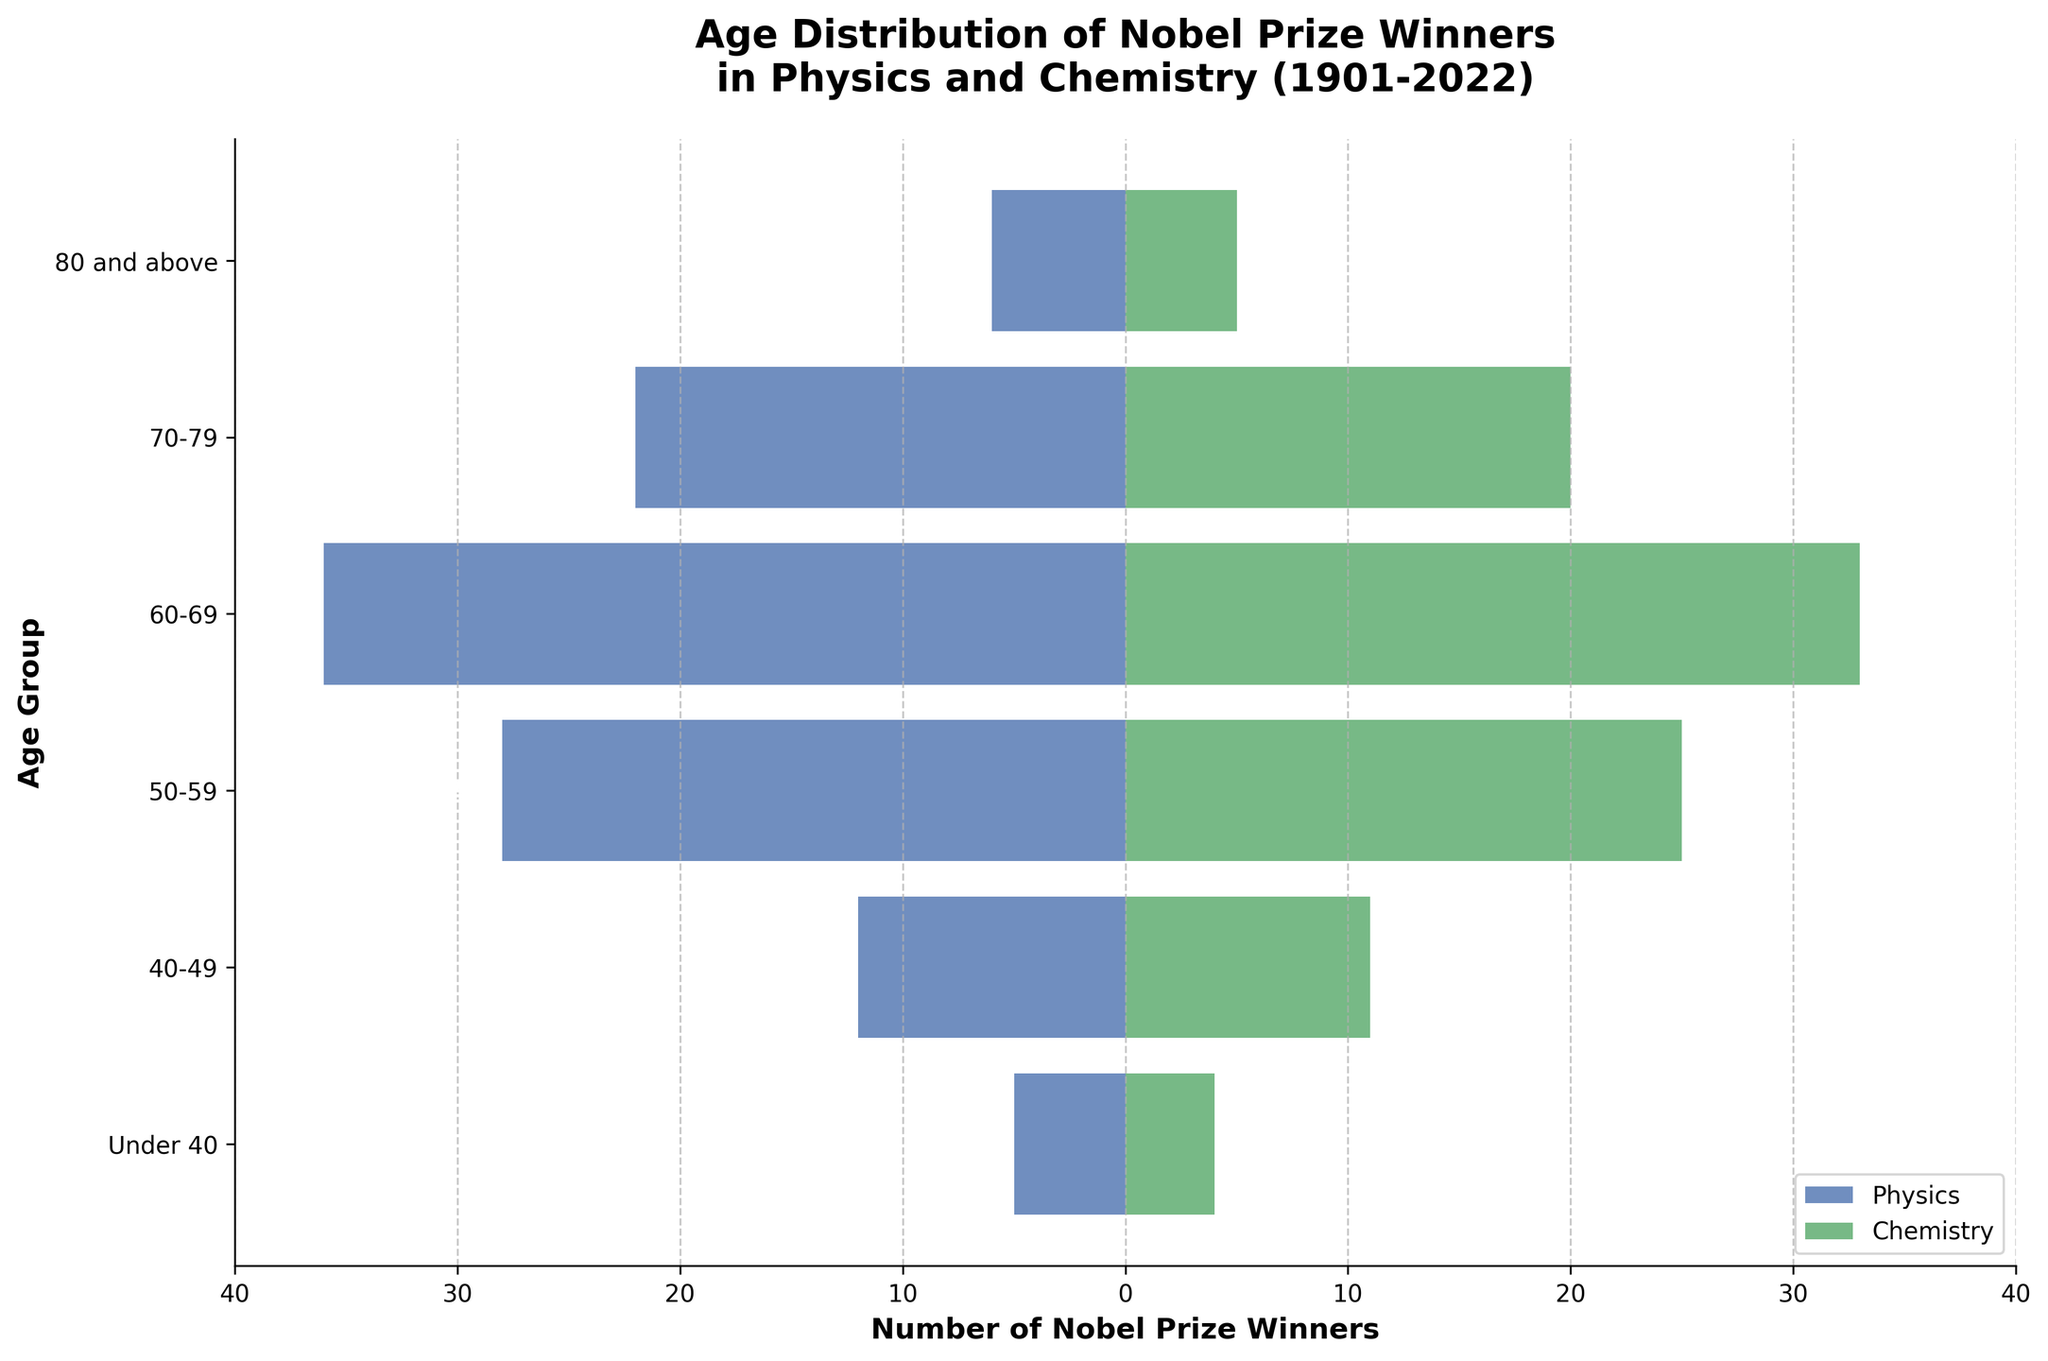what is the title of the figure? The title is located at the top of the figure and summarizes the content of the plot. The title is ‘Age Distribution of Nobel Prize Winners in Physics and Chemistry (1901-2022)’.
Answer: Age Distribution of Nobel Prize Winners in Physics and Chemistry (1901-2022) What is the age group with the most Nobel Prize winners in Physics? To identify the age group with the most winners, examine the length of the blue horizontal bars. The "60-69" age group has the longest bar in Physics.
Answer: 60-69 How many Nobel Prize winners in Chemistry are under the age of 40? Look at the green bar corresponding to the "Under 40" age group, the value indicated is 4.
Answer: 4 Compare the number of Nobel Prize winners in Physics and Chemistry in the "50-59" age group. Which has more, and by how much? The bar for Chemistry in the "50-59" age group is at 25, and for Physics, it is at -28. The Chemistry bar is longer. The difference is found by converting Physics to a positive value and calculating 28 - 25.
Answer: Chemistry by 3 How many age groups have more Nobel Prize winners in Physics than in Chemistry? Compare the lengths of bars for each age group. Physics exceeds Chemistry in "40-49", "50-59", and "60-69", so there are 3 such age groups.
Answer: 3 What is the total number of Nobel Prize winners in Chemistry across all age groups? Sum the values of the green bars: 4 (Under 40) + 11 (40-49) + 25 (50-59) + 33 (60-69) + 20 (70-79) + 5 (80 and above) = 98.
Answer: 98 In which age groups are there fewer than 10 winners in both Physics and Chemistry? Check the values in each age group and find those less than 10 for both fields: only "Under 40" fits this criterion (Physics: -5, Chemistry: 4).
Answer: Under 40 